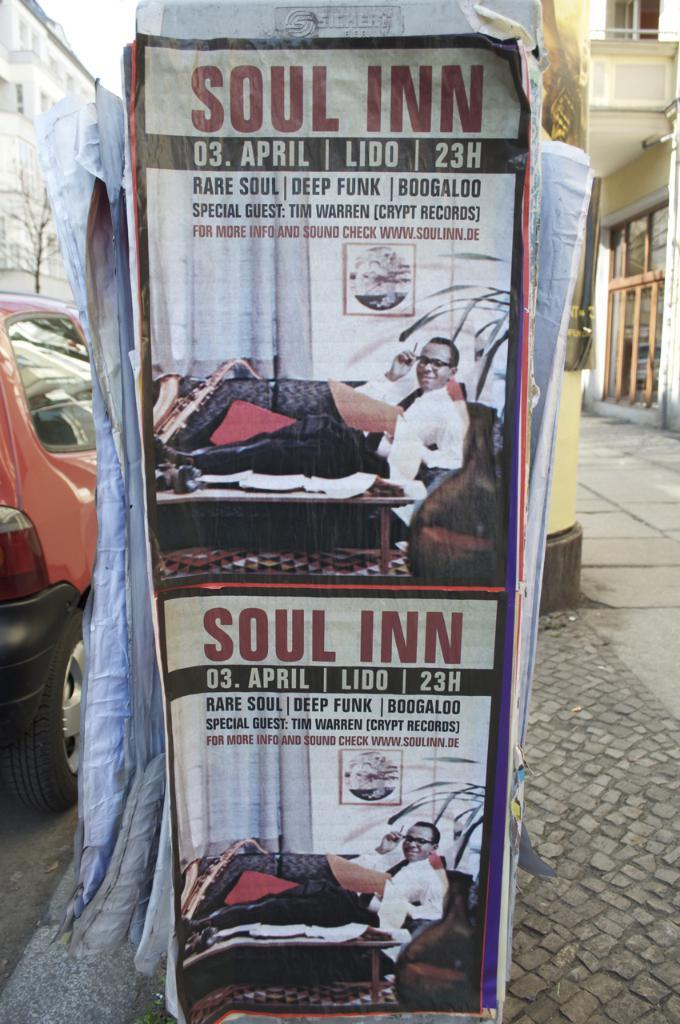What can be seen on the poster in the image? Unfortunately, the facts provided do not give any information about the content of the poster. What is located on the left side of the image? On the left side of the image, there is a car, a tree, and a building. How many buildings are visible in the image? There are two buildings visible in the image, one on the left side and one on the right side. What nation is represented by the surprise on the right side of the image? There is no nation, surprise, or any other object or element on the right side of the image, as the facts provided only mention a building on the right side. 